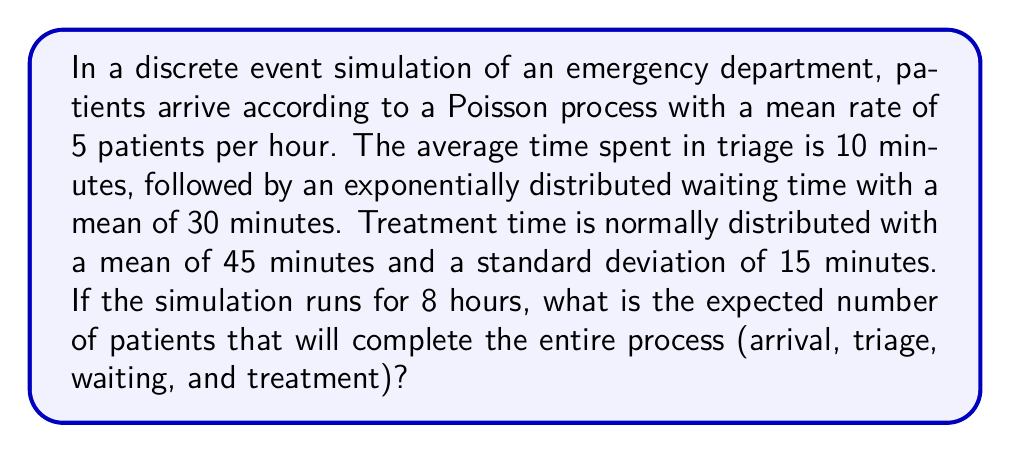Solve this math problem. Let's break this down step-by-step:

1) First, we need to calculate the expected number of patient arrivals in 8 hours:
   - Arrival rate = 5 patients/hour
   - Time = 8 hours
   - Expected arrivals = $5 \times 8 = 40$ patients

2) Now, let's calculate the average time a patient spends in the system:
   - Triage time: 10 minutes = 1/6 hour
   - Average waiting time: 30 minutes = 1/2 hour
   - Average treatment time: 45 minutes = 3/4 hour
   - Total average time = $\frac{1}{6} + \frac{1}{2} + \frac{3}{4} = \frac{17}{12}$ hours

3) In a stable system, the number of patients completing the process would be equal to the number of arrivals. However, we need to account for patients who are still in the system at the end of the 8-hour period.

4) We can estimate the number of patients still in the system using Little's Law:
   $L = \lambda W$
   Where $L$ is the average number of patients in the system, $\lambda$ is the arrival rate, and $W$ is the average time in the system.

   $L = 5 \times \frac{17}{12} \approx 7.08$ patients

5) Therefore, the expected number of patients completing the process is:
   Expected completions = Expected arrivals - Average patients in system
   $= 40 - 7.08 \approx 32.92$

6) Since we can't have a fractional number of patients, we round down to the nearest whole number.
Answer: 32 patients 